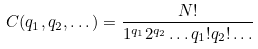<formula> <loc_0><loc_0><loc_500><loc_500>C ( q _ { 1 } , q _ { 2 } , \dots ) = \frac { N ! } { 1 ^ { q _ { 1 } } 2 ^ { q _ { 2 } } \dots q _ { 1 } ! q _ { 2 } ! \dots }</formula> 